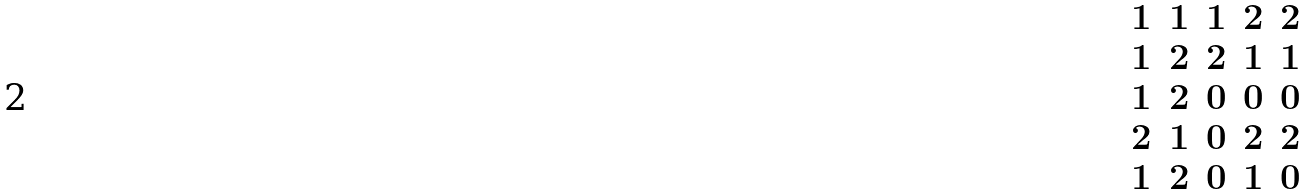Convert formula to latex. <formula><loc_0><loc_0><loc_500><loc_500>\begin{matrix} 1 & 1 & 1 & 2 & 2 \\ 1 & 2 & 2 & 1 & 1 \\ 1 & 2 & 0 & 0 & 0 \\ 2 & 1 & 0 & 2 & 2 \\ 1 & 2 & 0 & 1 & 0 \\ \end{matrix}</formula> 